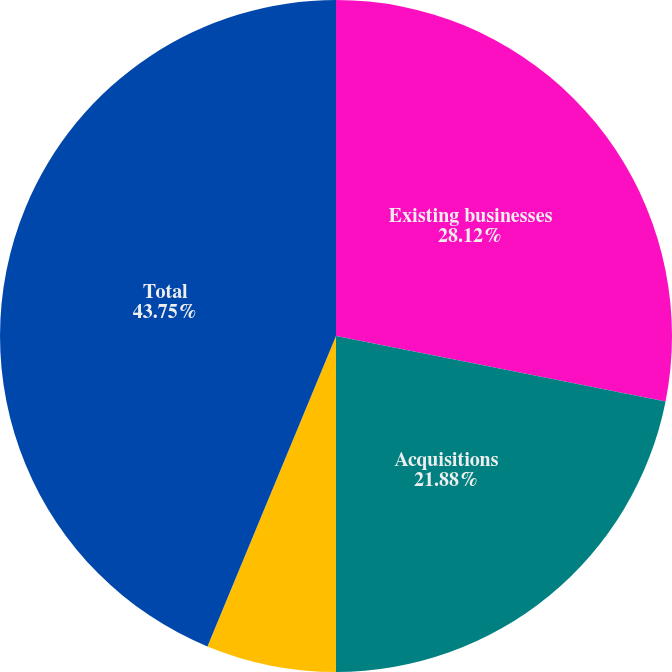<chart> <loc_0><loc_0><loc_500><loc_500><pie_chart><fcel>Existing businesses<fcel>Acquisitions<fcel>Currency exchange rates<fcel>Total<nl><fcel>28.12%<fcel>21.88%<fcel>6.25%<fcel>43.75%<nl></chart> 